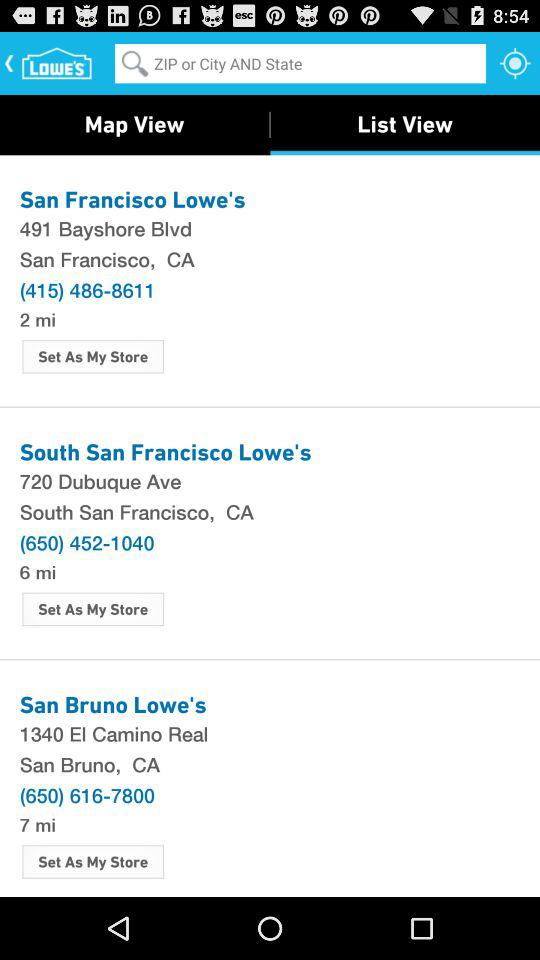What is the location of the South San Francisco Lowe's? The location is 720 Dubuque Ave, South San Francisco, CA. 